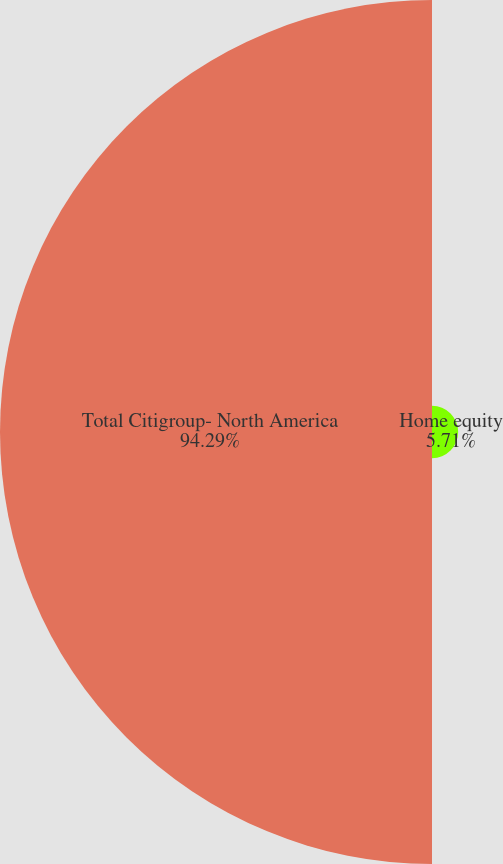<chart> <loc_0><loc_0><loc_500><loc_500><pie_chart><fcel>Home equity<fcel>Total Citigroup- North America<nl><fcel>5.71%<fcel>94.29%<nl></chart> 